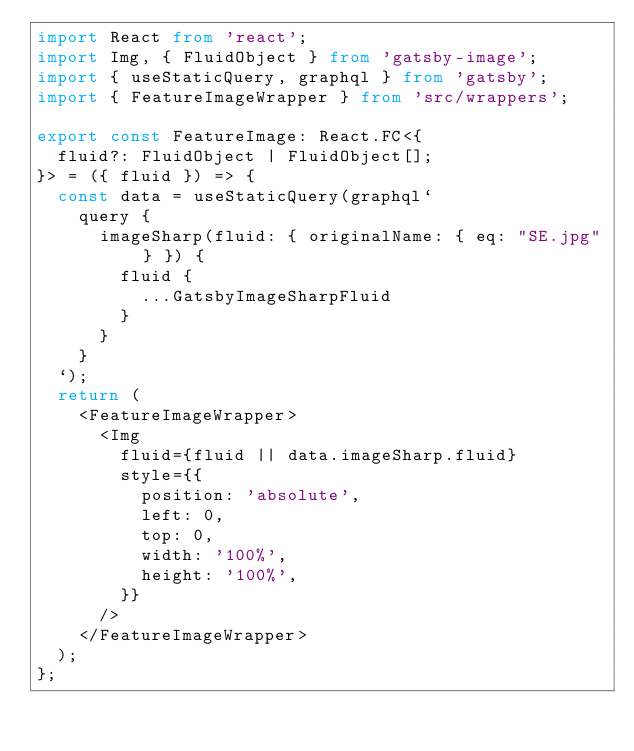<code> <loc_0><loc_0><loc_500><loc_500><_TypeScript_>import React from 'react';
import Img, { FluidObject } from 'gatsby-image';
import { useStaticQuery, graphql } from 'gatsby';
import { FeatureImageWrapper } from 'src/wrappers';

export const FeatureImage: React.FC<{
  fluid?: FluidObject | FluidObject[];
}> = ({ fluid }) => {
  const data = useStaticQuery(graphql`
    query {
      imageSharp(fluid: { originalName: { eq: "SE.jpg" } }) {
        fluid {
          ...GatsbyImageSharpFluid
        }
      }
    }
  `);
  return (
    <FeatureImageWrapper>
      <Img
        fluid={fluid || data.imageSharp.fluid}
        style={{
          position: 'absolute',
          left: 0,
          top: 0,
          width: '100%',
          height: '100%',
        }}
      />
    </FeatureImageWrapper>
  );
};
</code> 